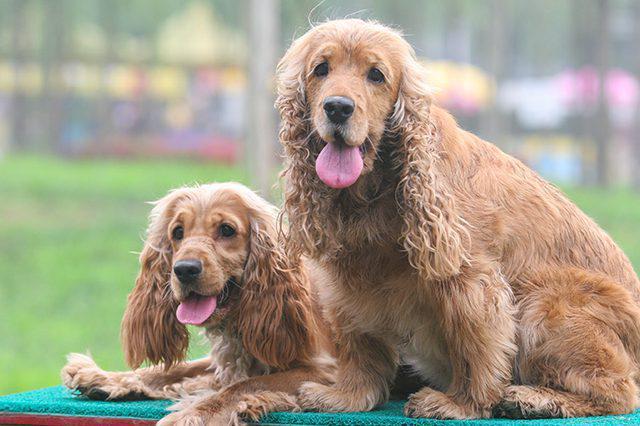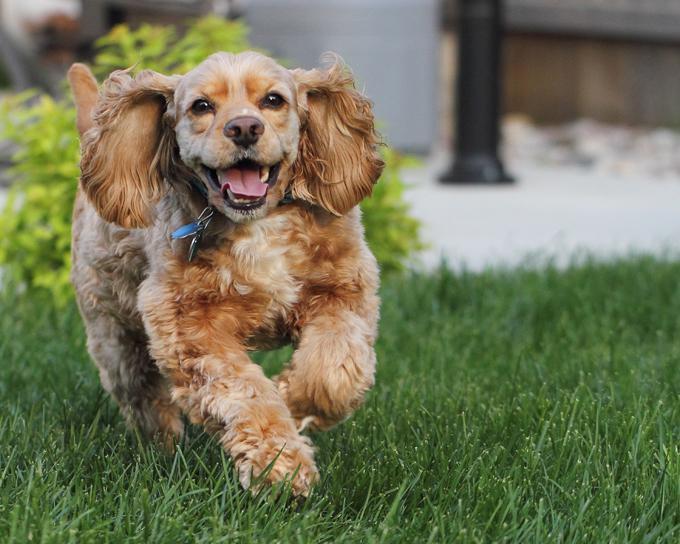The first image is the image on the left, the second image is the image on the right. Assess this claim about the two images: "The dog in the image on the right is outside on the grass.". Correct or not? Answer yes or no. Yes. The first image is the image on the left, the second image is the image on the right. Assess this claim about the two images: "The left image includes exactly twice as many spaniel dogs as the right image.". Correct or not? Answer yes or no. Yes. 